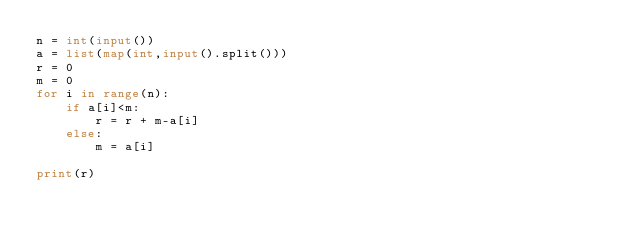Convert code to text. <code><loc_0><loc_0><loc_500><loc_500><_Python_>n = int(input())
a = list(map(int,input().split()))
r = 0
m = 0
for i in range(n):
    if a[i]<m:
        r = r + m-a[i]
    else:
        m = a[i]

print(r)</code> 